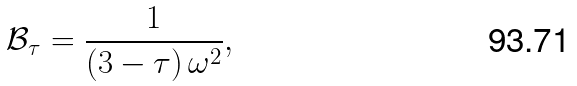<formula> <loc_0><loc_0><loc_500><loc_500>\mathcal { B } _ { \tau } = \frac { 1 } { ( 3 - \tau ) \, \omega ^ { 2 } } ,</formula> 